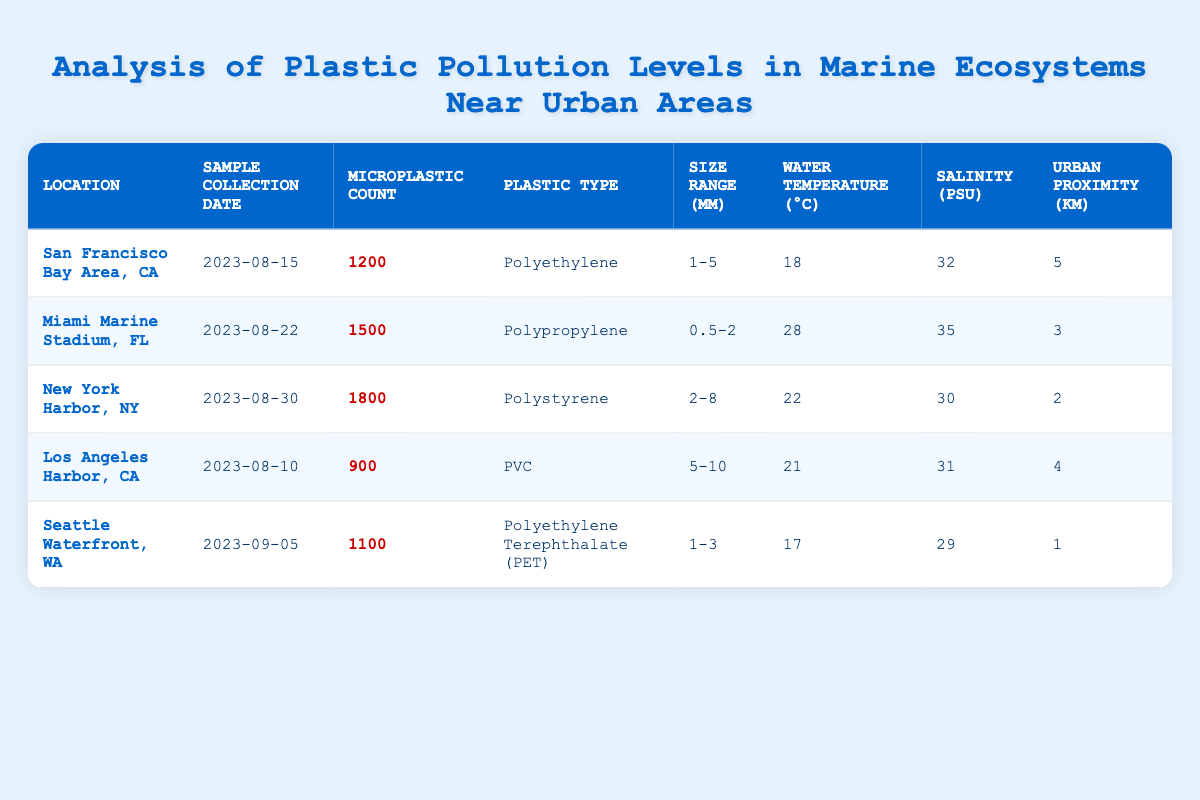What is the microplastic count in New York Harbor, NY? The table shows that the microplastic count for New York Harbor is listed in the corresponding row under the "Microplastic Count" column, which states that it is 1800.
Answer: 1800 What type of plastic was found in the water sample from Miami Marine Stadium, FL? By looking at the row for Miami Marine Stadium, the "Plastic Type" column indicates that the type of plastic found is Polypropylene.
Answer: Polypropylene Which location had the highest microplastic count, and what was that count? By comparing the "Microplastic Count" values in each row, New York Harbor has the highest count at 1800. This conclusion is reached by identifying and contrasting all counts listed in the table.
Answer: New York Harbor; 1800 What is the average water temperature of the locations in this study? The water temperatures are 18, 28, 22, 21, and 17 degrees Celsius. Summing these gives 106, and dividing by the 5 locations yields an average of 106/5 = 21.2.
Answer: 21.2 Is the salinity level in Miami Marine Stadium higher than that in Seattle Waterfront? The table shows Miami Marine Stadium's salinity at 35 PSU and Seattle Waterfront's at 29 PSU. Since 35 is greater than 29, the answer is yes.
Answer: Yes What is the total number of microplastics detected in locations within 5 km of urban areas? Summing the microplastic counts for San Francisco Bay Area (1200), Miami Marine Stadium (1500), New York Harbor (1800), and Los Angeles Harbor (900), we get 1200 + 1500 + 1800 + 900 = 4400. Seattle is also 1 km from urban, so adding 1100 gives a total of 5500.
Answer: 5500 In which location was the highest count of PVC detected and what was the value? The table shows that Los Angeles Harbor had a plastic type of PVC with a microplastic count of 900, higher than any other value for PVC, making this the highest count for that type.
Answer: Los Angeles Harbor; 900 Is the size range of microplastics in Seattle Waterfront larger than in San Francisco Bay Area? The size range for Seattle Waterfront is 1-3 mm, while for San Francisco Bay Area, it is 1-5 mm. Since 1-5 encompasses a larger range than 1-3, the answer is no.
Answer: No 